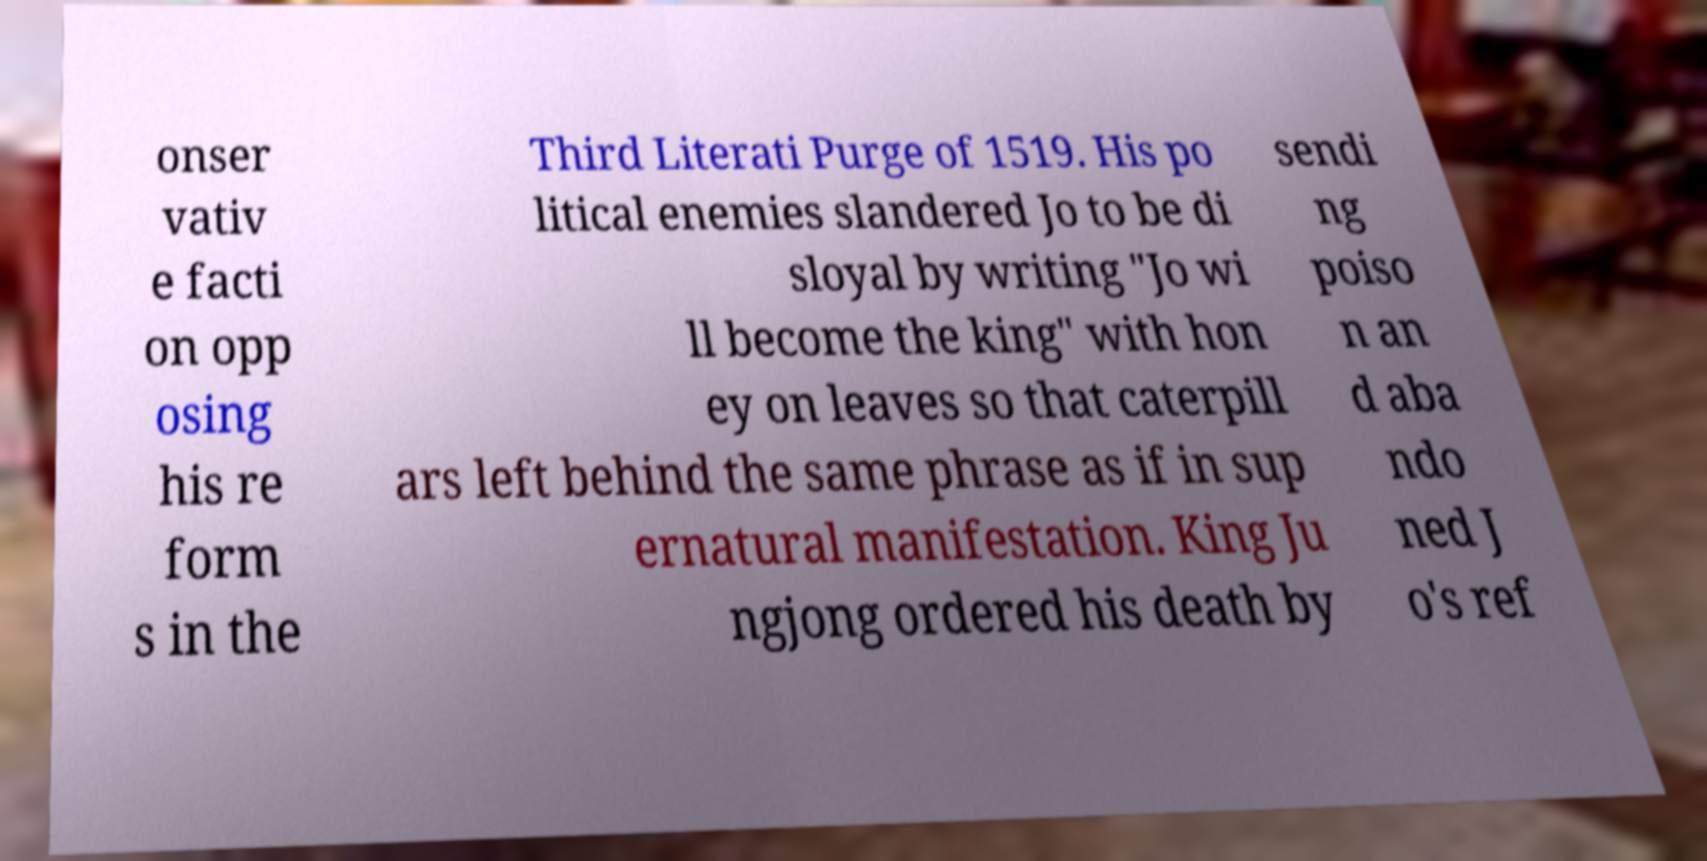Can you accurately transcribe the text from the provided image for me? onser vativ e facti on opp osing his re form s in the Third Literati Purge of 1519. His po litical enemies slandered Jo to be di sloyal by writing "Jo wi ll become the king" with hon ey on leaves so that caterpill ars left behind the same phrase as if in sup ernatural manifestation. King Ju ngjong ordered his death by sendi ng poiso n an d aba ndo ned J o's ref 